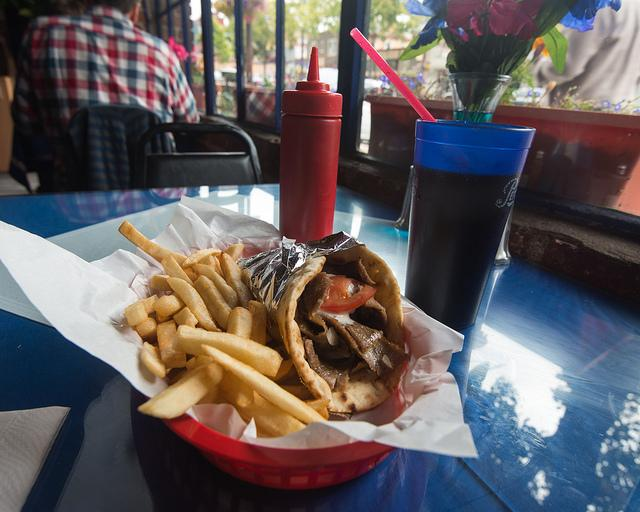What type of food is in the tinfoil? gyro 